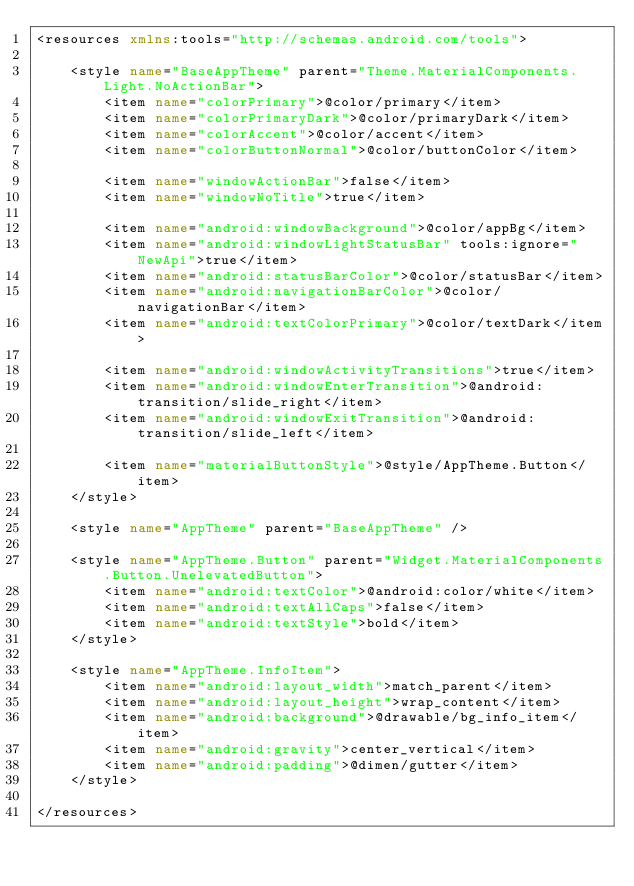Convert code to text. <code><loc_0><loc_0><loc_500><loc_500><_XML_><resources xmlns:tools="http://schemas.android.com/tools">

    <style name="BaseAppTheme" parent="Theme.MaterialComponents.Light.NoActionBar">
        <item name="colorPrimary">@color/primary</item>
        <item name="colorPrimaryDark">@color/primaryDark</item>
        <item name="colorAccent">@color/accent</item>
        <item name="colorButtonNormal">@color/buttonColor</item>

        <item name="windowActionBar">false</item>
        <item name="windowNoTitle">true</item>

        <item name="android:windowBackground">@color/appBg</item>
        <item name="android:windowLightStatusBar" tools:ignore="NewApi">true</item>
        <item name="android:statusBarColor">@color/statusBar</item>
        <item name="android:navigationBarColor">@color/navigationBar</item>
        <item name="android:textColorPrimary">@color/textDark</item>

        <item name="android:windowActivityTransitions">true</item>
        <item name="android:windowEnterTransition">@android:transition/slide_right</item>
        <item name="android:windowExitTransition">@android:transition/slide_left</item>

        <item name="materialButtonStyle">@style/AppTheme.Button</item>
    </style>

    <style name="AppTheme" parent="BaseAppTheme" />

    <style name="AppTheme.Button" parent="Widget.MaterialComponents.Button.UnelevatedButton">
        <item name="android:textColor">@android:color/white</item>
        <item name="android:textAllCaps">false</item>
        <item name="android:textStyle">bold</item>
    </style>

    <style name="AppTheme.InfoItem">
        <item name="android:layout_width">match_parent</item>
        <item name="android:layout_height">wrap_content</item>
        <item name="android:background">@drawable/bg_info_item</item>
        <item name="android:gravity">center_vertical</item>
        <item name="android:padding">@dimen/gutter</item>
    </style>

</resources>
</code> 